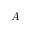<formula> <loc_0><loc_0><loc_500><loc_500>A</formula> 